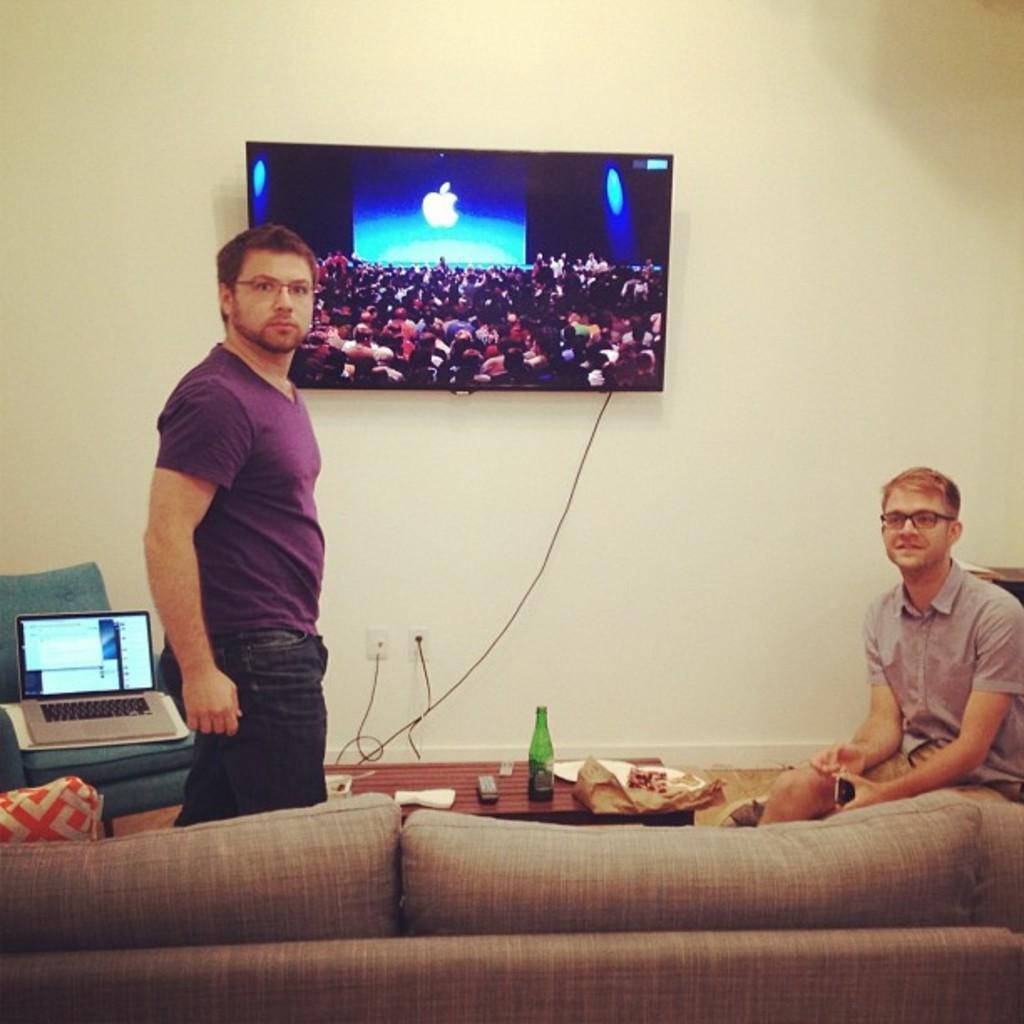Can you describe this image briefly? A person is standing in this image. At right side there is another person is sitting and smiling holding mobile in his hand. At the bottom of the image there is a sofa. Left corner there is a chair having laptop on it. A television is mounted on the wall. There is a table in the image and having a bottle and a bag on it. 